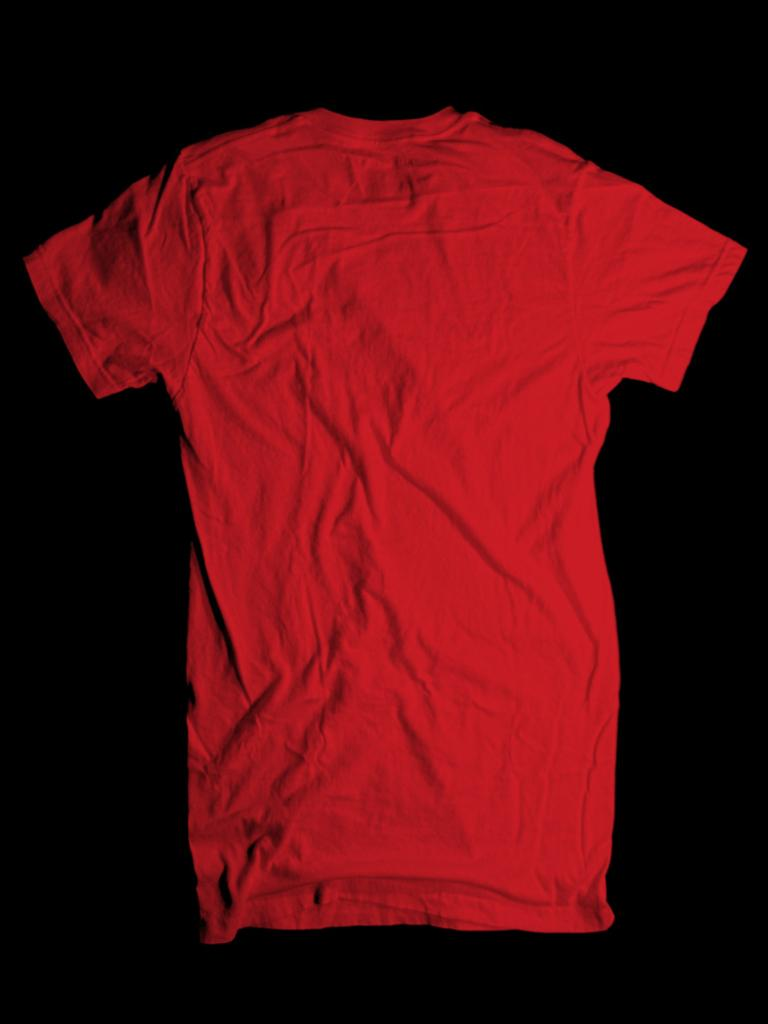What color is the t-shirt in the image? The t-shirt in the image is red. What is the t-shirt placed on in the image? The t-shirt is on a black surface. How many snails can be seen crawling on the red t-shirt in the image? There are no snails visible on the red t-shirt in the image. 